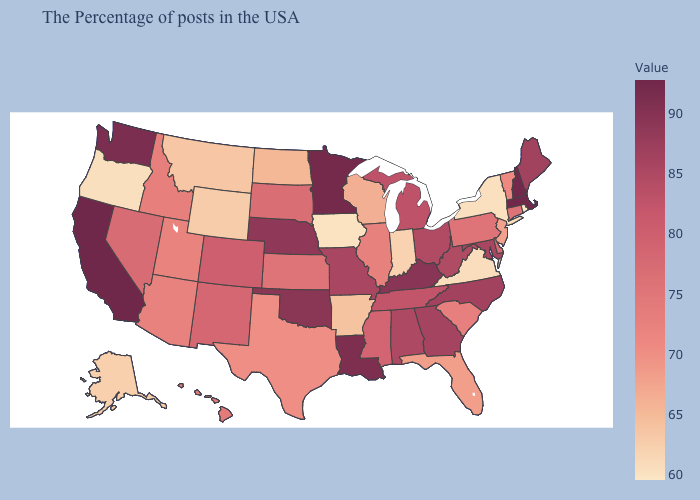Which states have the highest value in the USA?
Keep it brief. California. Does Rhode Island have the lowest value in the USA?
Quick response, please. Yes. Among the states that border Virginia , does Kentucky have the highest value?
Concise answer only. Yes. Is the legend a continuous bar?
Quick response, please. Yes. Does the map have missing data?
Give a very brief answer. No. 